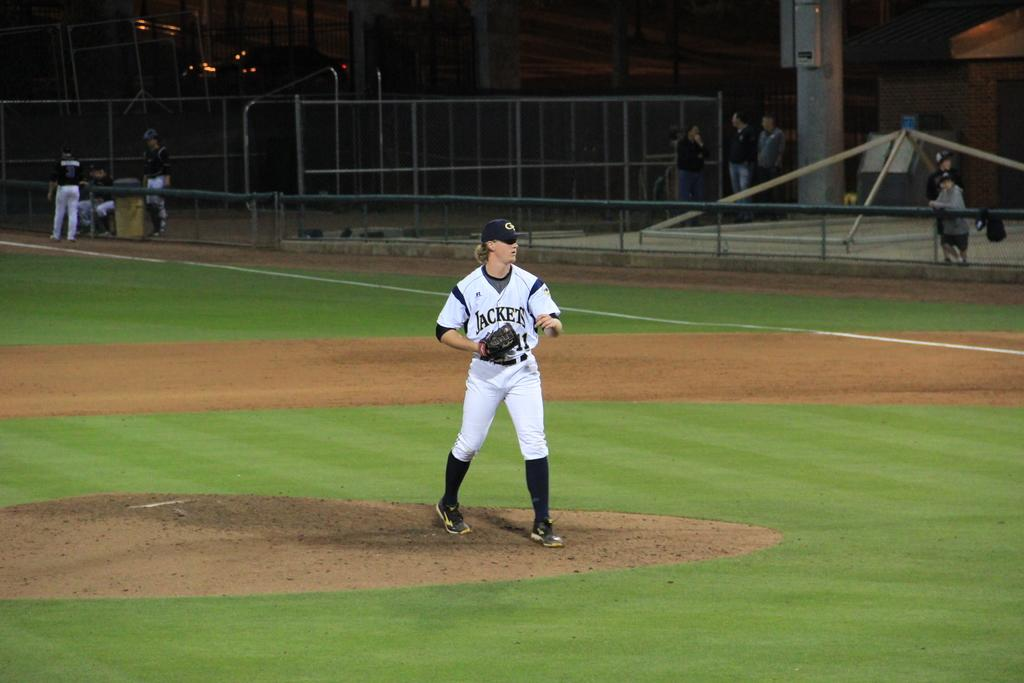<image>
Summarize the visual content of the image. A pitcher for the Jackets on the pitcher's mound during a game. 